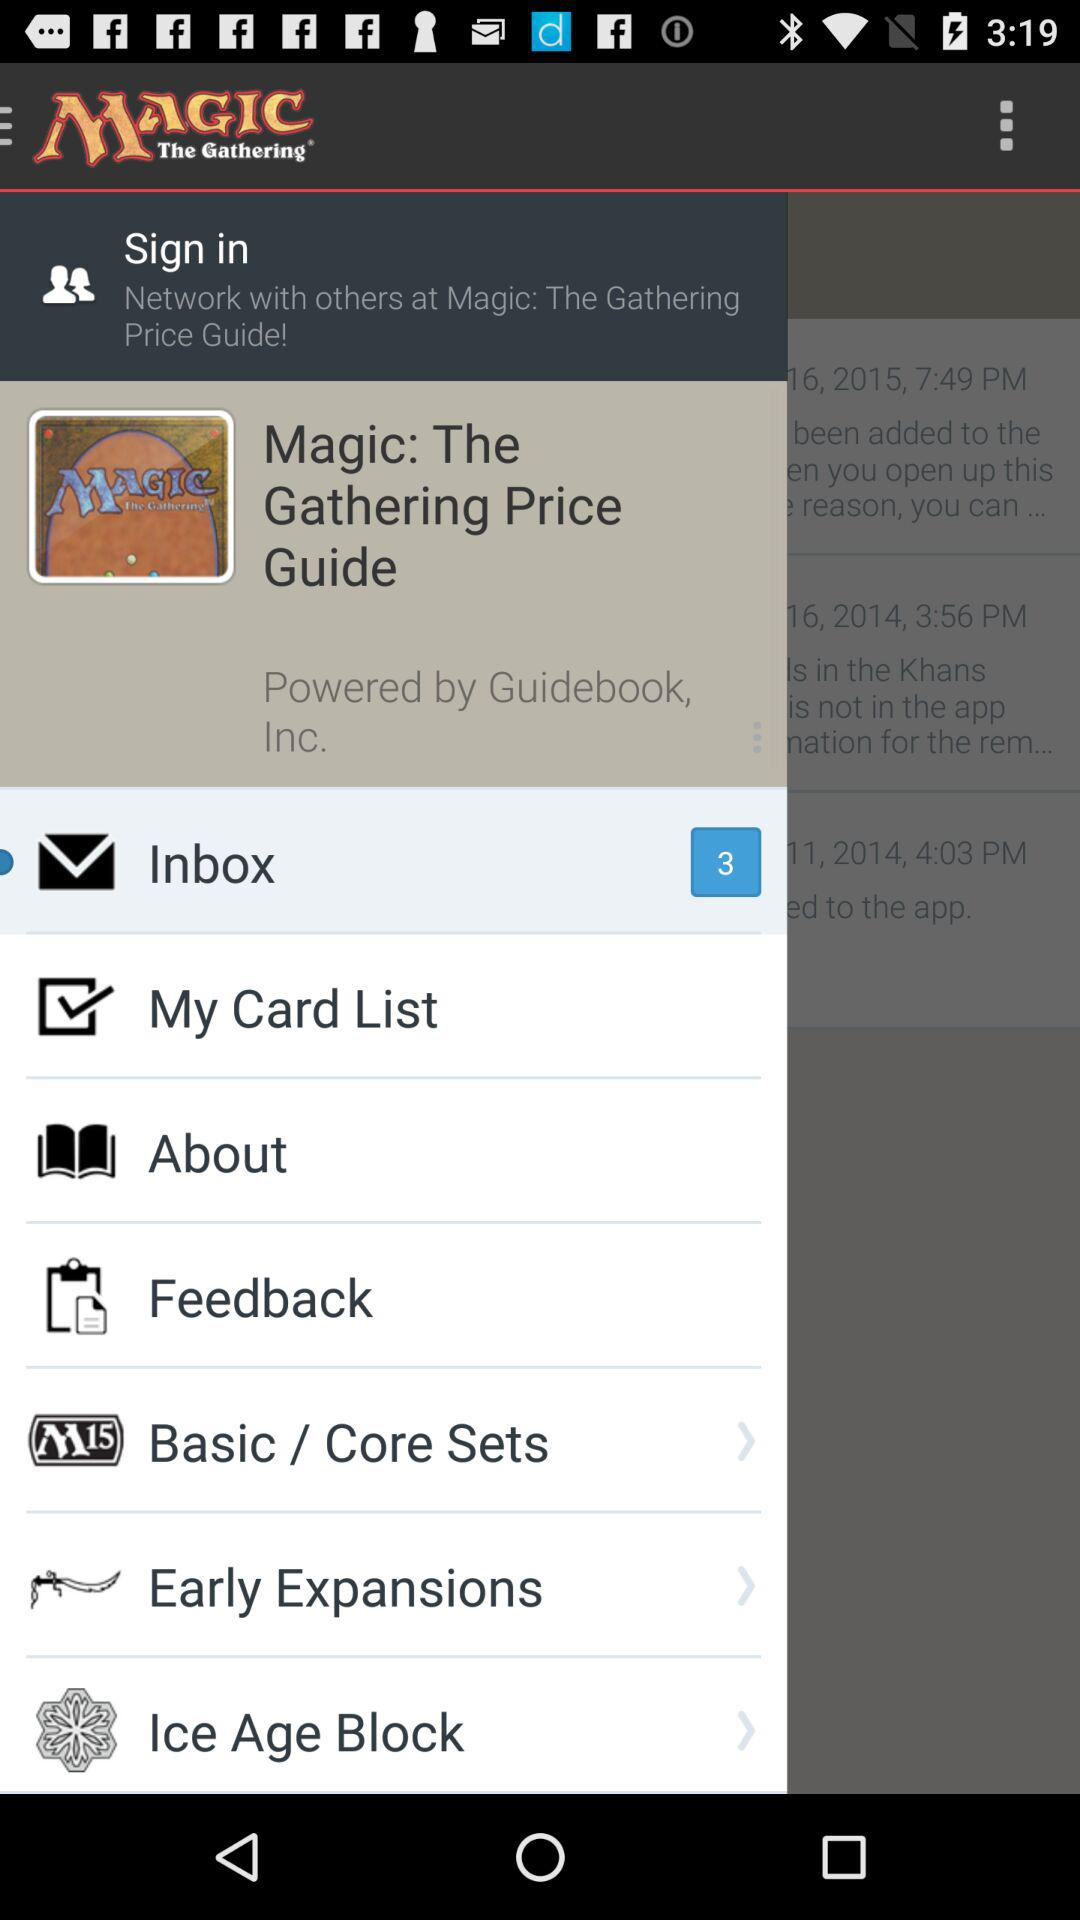How many messages are in the "Inbox"? There are 3 messages in the "Inbox". 